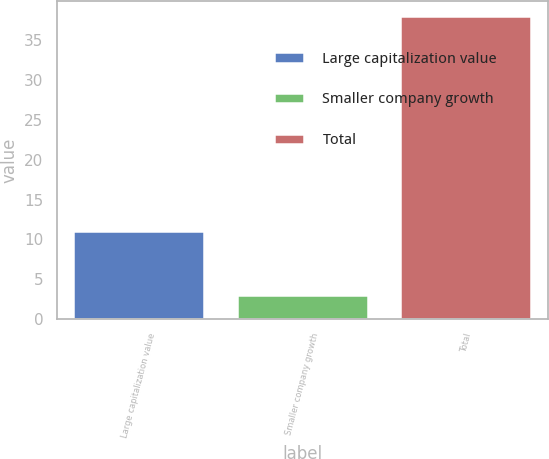<chart> <loc_0><loc_0><loc_500><loc_500><bar_chart><fcel>Large capitalization value<fcel>Smaller company growth<fcel>Total<nl><fcel>11<fcel>3<fcel>38<nl></chart> 